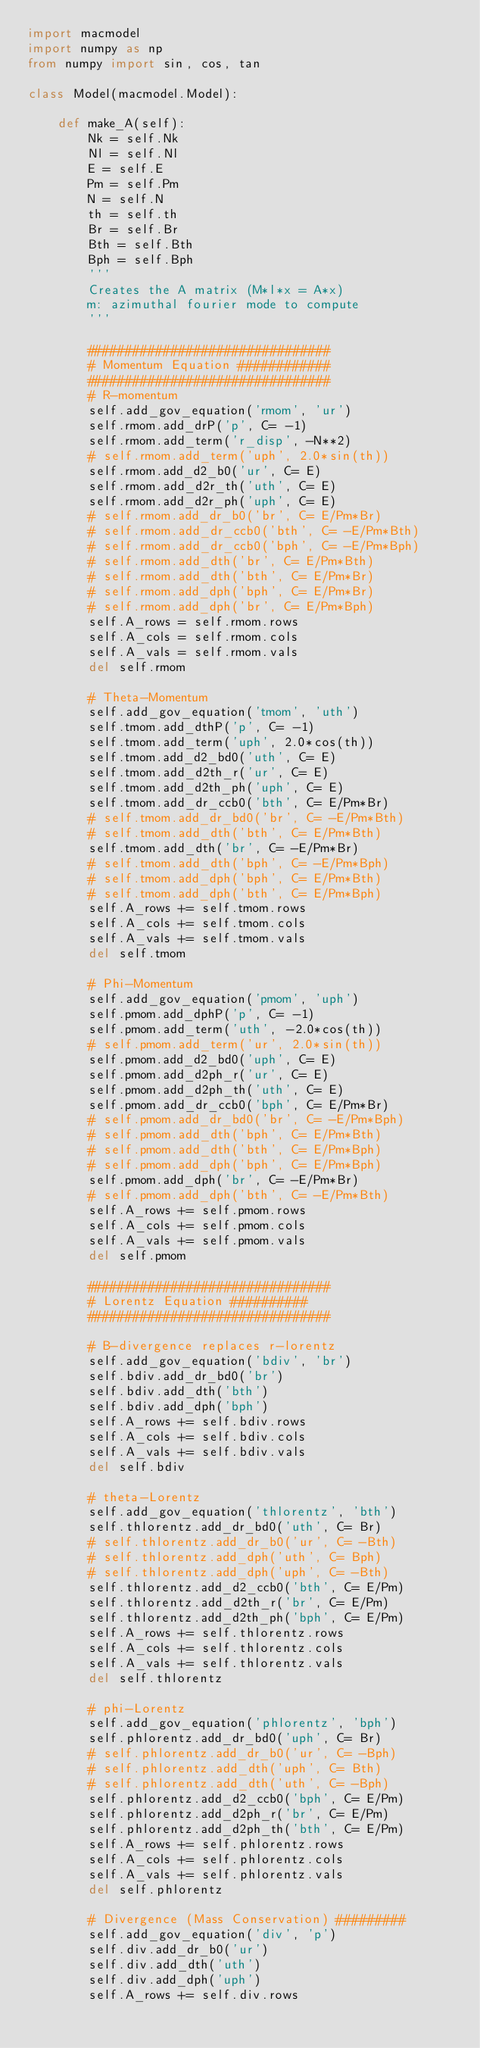Convert code to text. <code><loc_0><loc_0><loc_500><loc_500><_Python_>import macmodel
import numpy as np
from numpy import sin, cos, tan

class Model(macmodel.Model):

    def make_A(self):
        Nk = self.Nk
        Nl = self.Nl
        E = self.E
        Pm = self.Pm
        N = self.N
        th = self.th
        Br = self.Br
        Bth = self.Bth
        Bph = self.Bph
        '''
        Creates the A matrix (M*l*x = A*x)
        m: azimuthal fourier mode to compute
        '''

        ################################
        # Momentum Equation ############
        ################################
        # R-momentum
        self.add_gov_equation('rmom', 'ur')
        self.rmom.add_drP('p', C= -1)
        self.rmom.add_term('r_disp', -N**2)
        # self.rmom.add_term('uph', 2.0*sin(th))
        self.rmom.add_d2_b0('ur', C= E)
        self.rmom.add_d2r_th('uth', C= E)
        self.rmom.add_d2r_ph('uph', C= E)
        # self.rmom.add_dr_b0('br', C= E/Pm*Br)
        # self.rmom.add_dr_ccb0('bth', C= -E/Pm*Bth)
        # self.rmom.add_dr_ccb0('bph', C= -E/Pm*Bph)
        # self.rmom.add_dth('br', C= E/Pm*Bth)
        # self.rmom.add_dth('bth', C= E/Pm*Br)
        # self.rmom.add_dph('bph', C= E/Pm*Br)
        # self.rmom.add_dph('br', C= E/Pm*Bph)
        self.A_rows = self.rmom.rows
        self.A_cols = self.rmom.cols
        self.A_vals = self.rmom.vals
        del self.rmom

        # Theta-Momentum
        self.add_gov_equation('tmom', 'uth')
        self.tmom.add_dthP('p', C= -1)
        self.tmom.add_term('uph', 2.0*cos(th))
        self.tmom.add_d2_bd0('uth', C= E)
        self.tmom.add_d2th_r('ur', C= E)
        self.tmom.add_d2th_ph('uph', C= E)
        self.tmom.add_dr_ccb0('bth', C= E/Pm*Br)
        # self.tmom.add_dr_bd0('br', C= -E/Pm*Bth)
        # self.tmom.add_dth('bth', C= E/Pm*Bth)
        self.tmom.add_dth('br', C= -E/Pm*Br)
        # self.tmom.add_dth('bph', C= -E/Pm*Bph)
        # self.tmom.add_dph('bph', C= E/Pm*Bth)
        # self.tmom.add_dph('bth', C= E/Pm*Bph)
        self.A_rows += self.tmom.rows
        self.A_cols += self.tmom.cols
        self.A_vals += self.tmom.vals
        del self.tmom

        # Phi-Momentum
        self.add_gov_equation('pmom', 'uph')
        self.pmom.add_dphP('p', C= -1)
        self.pmom.add_term('uth', -2.0*cos(th))
        # self.pmom.add_term('ur', 2.0*sin(th))
        self.pmom.add_d2_bd0('uph', C= E)
        self.pmom.add_d2ph_r('ur', C= E)
        self.pmom.add_d2ph_th('uth', C= E)
        self.pmom.add_dr_ccb0('bph', C= E/Pm*Br)
        # self.pmom.add_dr_bd0('br', C= -E/Pm*Bph)
        # self.pmom.add_dth('bph', C= E/Pm*Bth)
        # self.pmom.add_dth('bth', C= E/Pm*Bph)
        # self.pmom.add_dph('bph', C= E/Pm*Bph)
        self.pmom.add_dph('br', C= -E/Pm*Br)
        # self.pmom.add_dph('bth', C= -E/Pm*Bth)
        self.A_rows += self.pmom.rows
        self.A_cols += self.pmom.cols
        self.A_vals += self.pmom.vals
        del self.pmom

        ################################
        # Lorentz Equation ##########
        ################################

        # B-divergence replaces r-lorentz
        self.add_gov_equation('bdiv', 'br')
        self.bdiv.add_dr_bd0('br')
        self.bdiv.add_dth('bth')
        self.bdiv.add_dph('bph')
        self.A_rows += self.bdiv.rows
        self.A_cols += self.bdiv.cols
        self.A_vals += self.bdiv.vals
        del self.bdiv

        # theta-Lorentz
        self.add_gov_equation('thlorentz', 'bth')
        self.thlorentz.add_dr_bd0('uth', C= Br)
        # self.thlorentz.add_dr_b0('ur', C= -Bth)
        # self.thlorentz.add_dph('uth', C= Bph)
        # self.thlorentz.add_dph('uph', C= -Bth)
        self.thlorentz.add_d2_ccb0('bth', C= E/Pm)
        self.thlorentz.add_d2th_r('br', C= E/Pm)
        self.thlorentz.add_d2th_ph('bph', C= E/Pm)
        self.A_rows += self.thlorentz.rows
        self.A_cols += self.thlorentz.cols
        self.A_vals += self.thlorentz.vals
        del self.thlorentz

        # phi-Lorentz
        self.add_gov_equation('phlorentz', 'bph')
        self.phlorentz.add_dr_bd0('uph', C= Br)
        # self.phlorentz.add_dr_b0('ur', C= -Bph)
        # self.phlorentz.add_dth('uph', C= Bth)
        # self.phlorentz.add_dth('uth', C= -Bph)
        self.phlorentz.add_d2_ccb0('bph', C= E/Pm)
        self.phlorentz.add_d2ph_r('br', C= E/Pm)
        self.phlorentz.add_d2ph_th('bth', C= E/Pm)
        self.A_rows += self.phlorentz.rows
        self.A_cols += self.phlorentz.cols
        self.A_vals += self.phlorentz.vals
        del self.phlorentz

        # Divergence (Mass Conservation) #########
        self.add_gov_equation('div', 'p')
        self.div.add_dr_b0('ur')
        self.div.add_dth('uth')
        self.div.add_dph('uph')
        self.A_rows += self.div.rows</code> 